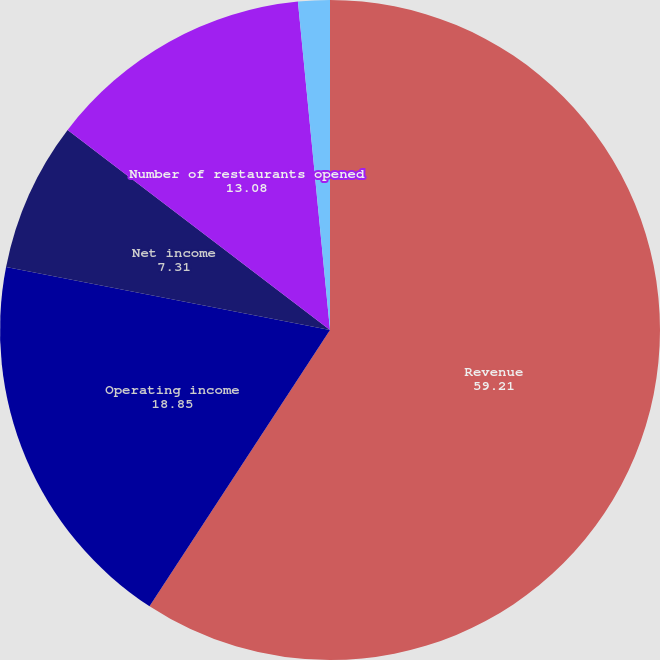Convert chart. <chart><loc_0><loc_0><loc_500><loc_500><pie_chart><fcel>Revenue<fcel>Operating income<fcel>Net income<fcel>Number of restaurants opened<fcel>Comparable restaurant sales<nl><fcel>59.21%<fcel>18.85%<fcel>7.31%<fcel>13.08%<fcel>1.55%<nl></chart> 